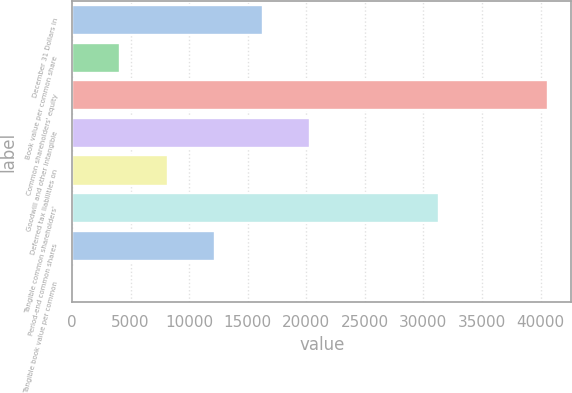<chart> <loc_0><loc_0><loc_500><loc_500><bar_chart><fcel>December 31 Dollars in<fcel>Book value per common share<fcel>Common shareholders' equity<fcel>Goodwill and other intangible<fcel>Deferred tax liabilities on<fcel>Tangible common shareholders'<fcel>Period-end common shares<fcel>Tangible book value per common<nl><fcel>16277.9<fcel>4114.39<fcel>40605<fcel>20332.4<fcel>8168.9<fcel>31330<fcel>12223.4<fcel>59.88<nl></chart> 